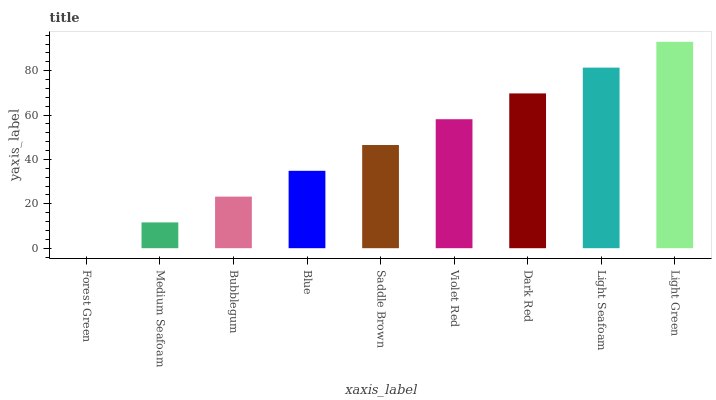Is Forest Green the minimum?
Answer yes or no. Yes. Is Light Green the maximum?
Answer yes or no. Yes. Is Medium Seafoam the minimum?
Answer yes or no. No. Is Medium Seafoam the maximum?
Answer yes or no. No. Is Medium Seafoam greater than Forest Green?
Answer yes or no. Yes. Is Forest Green less than Medium Seafoam?
Answer yes or no. Yes. Is Forest Green greater than Medium Seafoam?
Answer yes or no. No. Is Medium Seafoam less than Forest Green?
Answer yes or no. No. Is Saddle Brown the high median?
Answer yes or no. Yes. Is Saddle Brown the low median?
Answer yes or no. Yes. Is Medium Seafoam the high median?
Answer yes or no. No. Is Light Green the low median?
Answer yes or no. No. 